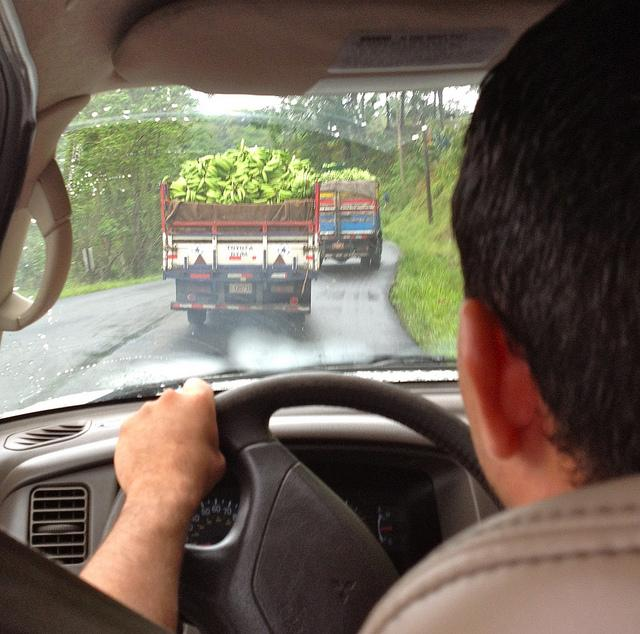What are the chances that at least one banana will fall out of the truck?

Choices:
A) high
B) impossible
C) very low
D) low high 